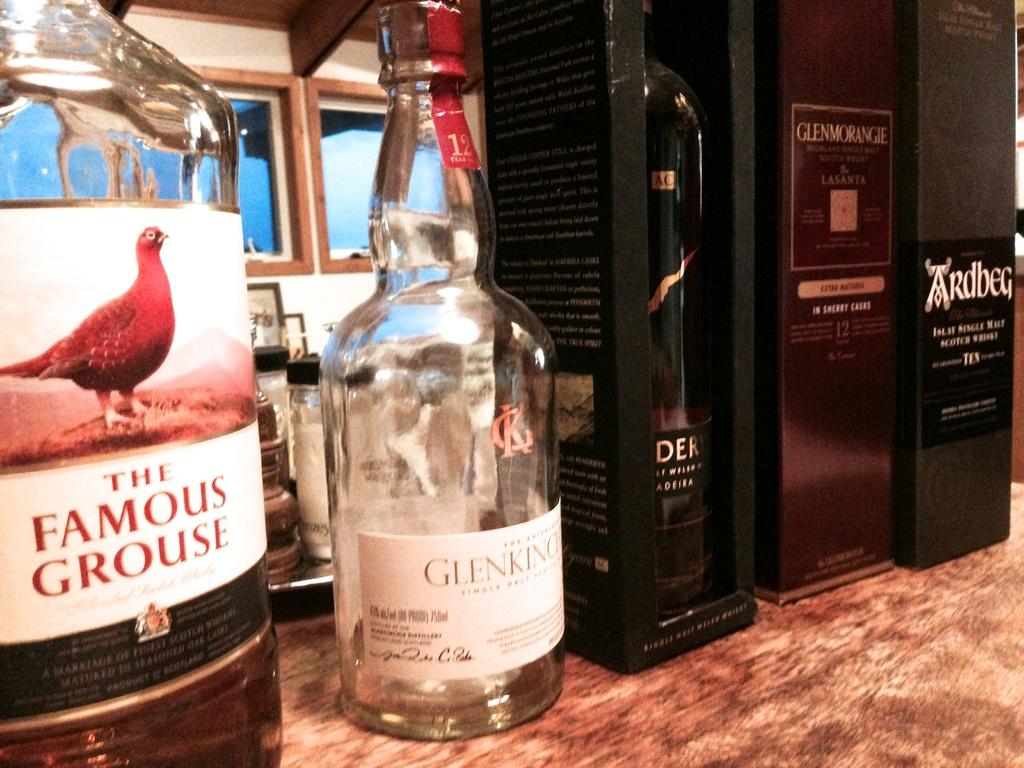What type of items can be seen in the image? There are alcohol bottles in the image. How are the bottles arranged or stored? Some of the bottles are in a box, and they are all on a table. What can be seen on the background wall? There are windows on the background wall. What type of paste is being used to write a fictional story on the wall in the image? There is no paste or writing on the wall in the image; it only features alcohol bottles, a box, and a table. 